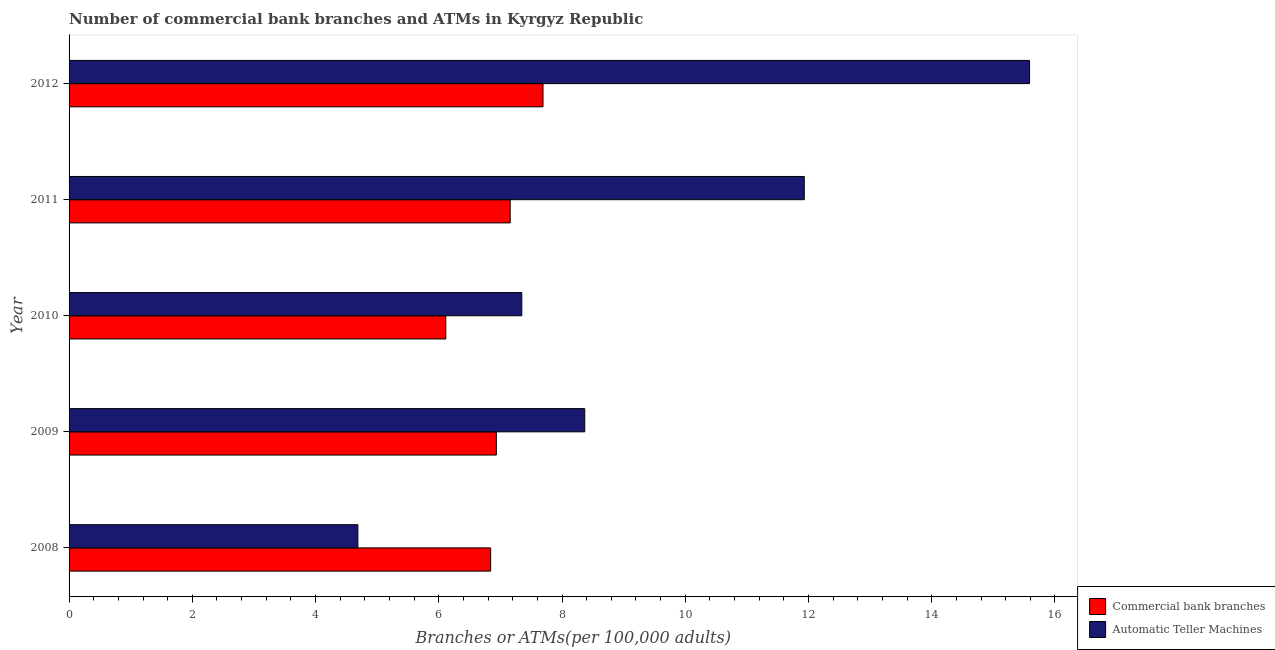How many different coloured bars are there?
Ensure brevity in your answer.  2. How many groups of bars are there?
Your answer should be compact. 5. Are the number of bars on each tick of the Y-axis equal?
Make the answer very short. Yes. How many bars are there on the 2nd tick from the top?
Keep it short and to the point. 2. What is the label of the 1st group of bars from the top?
Offer a terse response. 2012. What is the number of commercal bank branches in 2008?
Provide a succinct answer. 6.84. Across all years, what is the maximum number of atms?
Offer a very short reply. 15.59. Across all years, what is the minimum number of commercal bank branches?
Make the answer very short. 6.11. What is the total number of commercal bank branches in the graph?
Your answer should be very brief. 34.74. What is the difference between the number of commercal bank branches in 2009 and that in 2010?
Your response must be concise. 0.82. What is the difference between the number of commercal bank branches in 2009 and the number of atms in 2012?
Offer a terse response. -8.65. What is the average number of commercal bank branches per year?
Give a very brief answer. 6.95. In the year 2012, what is the difference between the number of atms and number of commercal bank branches?
Offer a very short reply. 7.9. What is the ratio of the number of atms in 2009 to that in 2012?
Your answer should be compact. 0.54. Is the number of commercal bank branches in 2010 less than that in 2012?
Provide a short and direct response. Yes. Is the difference between the number of atms in 2011 and 2012 greater than the difference between the number of commercal bank branches in 2011 and 2012?
Keep it short and to the point. No. What is the difference between the highest and the second highest number of atms?
Your response must be concise. 3.66. What does the 2nd bar from the top in 2011 represents?
Your answer should be very brief. Commercial bank branches. What does the 1st bar from the bottom in 2012 represents?
Your answer should be very brief. Commercial bank branches. Are all the bars in the graph horizontal?
Provide a succinct answer. Yes. How many years are there in the graph?
Make the answer very short. 5. Does the graph contain grids?
Keep it short and to the point. No. Where does the legend appear in the graph?
Provide a succinct answer. Bottom right. What is the title of the graph?
Give a very brief answer. Number of commercial bank branches and ATMs in Kyrgyz Republic. Does "Primary completion rate" appear as one of the legend labels in the graph?
Provide a short and direct response. No. What is the label or title of the X-axis?
Keep it short and to the point. Branches or ATMs(per 100,0 adults). What is the label or title of the Y-axis?
Offer a very short reply. Year. What is the Branches or ATMs(per 100,000 adults) of Commercial bank branches in 2008?
Provide a succinct answer. 6.84. What is the Branches or ATMs(per 100,000 adults) of Automatic Teller Machines in 2008?
Ensure brevity in your answer.  4.69. What is the Branches or ATMs(per 100,000 adults) of Commercial bank branches in 2009?
Provide a succinct answer. 6.93. What is the Branches or ATMs(per 100,000 adults) in Automatic Teller Machines in 2009?
Give a very brief answer. 8.37. What is the Branches or ATMs(per 100,000 adults) in Commercial bank branches in 2010?
Your answer should be very brief. 6.11. What is the Branches or ATMs(per 100,000 adults) of Automatic Teller Machines in 2010?
Make the answer very short. 7.35. What is the Branches or ATMs(per 100,000 adults) of Commercial bank branches in 2011?
Ensure brevity in your answer.  7.16. What is the Branches or ATMs(per 100,000 adults) in Automatic Teller Machines in 2011?
Provide a succinct answer. 11.93. What is the Branches or ATMs(per 100,000 adults) of Commercial bank branches in 2012?
Provide a short and direct response. 7.69. What is the Branches or ATMs(per 100,000 adults) in Automatic Teller Machines in 2012?
Provide a short and direct response. 15.59. Across all years, what is the maximum Branches or ATMs(per 100,000 adults) of Commercial bank branches?
Your answer should be compact. 7.69. Across all years, what is the maximum Branches or ATMs(per 100,000 adults) in Automatic Teller Machines?
Ensure brevity in your answer.  15.59. Across all years, what is the minimum Branches or ATMs(per 100,000 adults) in Commercial bank branches?
Ensure brevity in your answer.  6.11. Across all years, what is the minimum Branches or ATMs(per 100,000 adults) of Automatic Teller Machines?
Ensure brevity in your answer.  4.69. What is the total Branches or ATMs(per 100,000 adults) of Commercial bank branches in the graph?
Make the answer very short. 34.74. What is the total Branches or ATMs(per 100,000 adults) of Automatic Teller Machines in the graph?
Keep it short and to the point. 47.92. What is the difference between the Branches or ATMs(per 100,000 adults) of Commercial bank branches in 2008 and that in 2009?
Give a very brief answer. -0.09. What is the difference between the Branches or ATMs(per 100,000 adults) in Automatic Teller Machines in 2008 and that in 2009?
Provide a succinct answer. -3.68. What is the difference between the Branches or ATMs(per 100,000 adults) in Commercial bank branches in 2008 and that in 2010?
Offer a terse response. 0.73. What is the difference between the Branches or ATMs(per 100,000 adults) in Automatic Teller Machines in 2008 and that in 2010?
Give a very brief answer. -2.66. What is the difference between the Branches or ATMs(per 100,000 adults) in Commercial bank branches in 2008 and that in 2011?
Offer a very short reply. -0.32. What is the difference between the Branches or ATMs(per 100,000 adults) of Automatic Teller Machines in 2008 and that in 2011?
Offer a terse response. -7.24. What is the difference between the Branches or ATMs(per 100,000 adults) of Commercial bank branches in 2008 and that in 2012?
Offer a terse response. -0.85. What is the difference between the Branches or ATMs(per 100,000 adults) of Automatic Teller Machines in 2008 and that in 2012?
Your answer should be very brief. -10.9. What is the difference between the Branches or ATMs(per 100,000 adults) in Commercial bank branches in 2009 and that in 2010?
Provide a succinct answer. 0.82. What is the difference between the Branches or ATMs(per 100,000 adults) of Automatic Teller Machines in 2009 and that in 2010?
Provide a short and direct response. 1.02. What is the difference between the Branches or ATMs(per 100,000 adults) of Commercial bank branches in 2009 and that in 2011?
Make the answer very short. -0.22. What is the difference between the Branches or ATMs(per 100,000 adults) of Automatic Teller Machines in 2009 and that in 2011?
Offer a very short reply. -3.56. What is the difference between the Branches or ATMs(per 100,000 adults) of Commercial bank branches in 2009 and that in 2012?
Your answer should be compact. -0.76. What is the difference between the Branches or ATMs(per 100,000 adults) of Automatic Teller Machines in 2009 and that in 2012?
Make the answer very short. -7.22. What is the difference between the Branches or ATMs(per 100,000 adults) of Commercial bank branches in 2010 and that in 2011?
Your response must be concise. -1.05. What is the difference between the Branches or ATMs(per 100,000 adults) in Automatic Teller Machines in 2010 and that in 2011?
Offer a terse response. -4.58. What is the difference between the Branches or ATMs(per 100,000 adults) in Commercial bank branches in 2010 and that in 2012?
Ensure brevity in your answer.  -1.58. What is the difference between the Branches or ATMs(per 100,000 adults) of Automatic Teller Machines in 2010 and that in 2012?
Provide a short and direct response. -8.24. What is the difference between the Branches or ATMs(per 100,000 adults) in Commercial bank branches in 2011 and that in 2012?
Your answer should be compact. -0.53. What is the difference between the Branches or ATMs(per 100,000 adults) of Automatic Teller Machines in 2011 and that in 2012?
Offer a terse response. -3.66. What is the difference between the Branches or ATMs(per 100,000 adults) of Commercial bank branches in 2008 and the Branches or ATMs(per 100,000 adults) of Automatic Teller Machines in 2009?
Your answer should be compact. -1.53. What is the difference between the Branches or ATMs(per 100,000 adults) of Commercial bank branches in 2008 and the Branches or ATMs(per 100,000 adults) of Automatic Teller Machines in 2010?
Keep it short and to the point. -0.51. What is the difference between the Branches or ATMs(per 100,000 adults) of Commercial bank branches in 2008 and the Branches or ATMs(per 100,000 adults) of Automatic Teller Machines in 2011?
Provide a succinct answer. -5.09. What is the difference between the Branches or ATMs(per 100,000 adults) in Commercial bank branches in 2008 and the Branches or ATMs(per 100,000 adults) in Automatic Teller Machines in 2012?
Ensure brevity in your answer.  -8.75. What is the difference between the Branches or ATMs(per 100,000 adults) in Commercial bank branches in 2009 and the Branches or ATMs(per 100,000 adults) in Automatic Teller Machines in 2010?
Make the answer very short. -0.41. What is the difference between the Branches or ATMs(per 100,000 adults) in Commercial bank branches in 2009 and the Branches or ATMs(per 100,000 adults) in Automatic Teller Machines in 2011?
Keep it short and to the point. -5. What is the difference between the Branches or ATMs(per 100,000 adults) of Commercial bank branches in 2009 and the Branches or ATMs(per 100,000 adults) of Automatic Teller Machines in 2012?
Provide a short and direct response. -8.65. What is the difference between the Branches or ATMs(per 100,000 adults) of Commercial bank branches in 2010 and the Branches or ATMs(per 100,000 adults) of Automatic Teller Machines in 2011?
Ensure brevity in your answer.  -5.82. What is the difference between the Branches or ATMs(per 100,000 adults) in Commercial bank branches in 2010 and the Branches or ATMs(per 100,000 adults) in Automatic Teller Machines in 2012?
Your answer should be very brief. -9.47. What is the difference between the Branches or ATMs(per 100,000 adults) of Commercial bank branches in 2011 and the Branches or ATMs(per 100,000 adults) of Automatic Teller Machines in 2012?
Offer a terse response. -8.43. What is the average Branches or ATMs(per 100,000 adults) of Commercial bank branches per year?
Ensure brevity in your answer.  6.95. What is the average Branches or ATMs(per 100,000 adults) of Automatic Teller Machines per year?
Offer a very short reply. 9.58. In the year 2008, what is the difference between the Branches or ATMs(per 100,000 adults) of Commercial bank branches and Branches or ATMs(per 100,000 adults) of Automatic Teller Machines?
Offer a very short reply. 2.15. In the year 2009, what is the difference between the Branches or ATMs(per 100,000 adults) in Commercial bank branches and Branches or ATMs(per 100,000 adults) in Automatic Teller Machines?
Provide a succinct answer. -1.43. In the year 2010, what is the difference between the Branches or ATMs(per 100,000 adults) in Commercial bank branches and Branches or ATMs(per 100,000 adults) in Automatic Teller Machines?
Provide a succinct answer. -1.23. In the year 2011, what is the difference between the Branches or ATMs(per 100,000 adults) in Commercial bank branches and Branches or ATMs(per 100,000 adults) in Automatic Teller Machines?
Make the answer very short. -4.77. In the year 2012, what is the difference between the Branches or ATMs(per 100,000 adults) of Commercial bank branches and Branches or ATMs(per 100,000 adults) of Automatic Teller Machines?
Your response must be concise. -7.9. What is the ratio of the Branches or ATMs(per 100,000 adults) in Commercial bank branches in 2008 to that in 2009?
Your response must be concise. 0.99. What is the ratio of the Branches or ATMs(per 100,000 adults) of Automatic Teller Machines in 2008 to that in 2009?
Offer a terse response. 0.56. What is the ratio of the Branches or ATMs(per 100,000 adults) of Commercial bank branches in 2008 to that in 2010?
Make the answer very short. 1.12. What is the ratio of the Branches or ATMs(per 100,000 adults) of Automatic Teller Machines in 2008 to that in 2010?
Your response must be concise. 0.64. What is the ratio of the Branches or ATMs(per 100,000 adults) of Commercial bank branches in 2008 to that in 2011?
Keep it short and to the point. 0.96. What is the ratio of the Branches or ATMs(per 100,000 adults) in Automatic Teller Machines in 2008 to that in 2011?
Keep it short and to the point. 0.39. What is the ratio of the Branches or ATMs(per 100,000 adults) in Commercial bank branches in 2008 to that in 2012?
Provide a short and direct response. 0.89. What is the ratio of the Branches or ATMs(per 100,000 adults) in Automatic Teller Machines in 2008 to that in 2012?
Your answer should be compact. 0.3. What is the ratio of the Branches or ATMs(per 100,000 adults) of Commercial bank branches in 2009 to that in 2010?
Provide a short and direct response. 1.13. What is the ratio of the Branches or ATMs(per 100,000 adults) in Automatic Teller Machines in 2009 to that in 2010?
Your response must be concise. 1.14. What is the ratio of the Branches or ATMs(per 100,000 adults) in Commercial bank branches in 2009 to that in 2011?
Provide a succinct answer. 0.97. What is the ratio of the Branches or ATMs(per 100,000 adults) of Automatic Teller Machines in 2009 to that in 2011?
Keep it short and to the point. 0.7. What is the ratio of the Branches or ATMs(per 100,000 adults) of Commercial bank branches in 2009 to that in 2012?
Offer a terse response. 0.9. What is the ratio of the Branches or ATMs(per 100,000 adults) of Automatic Teller Machines in 2009 to that in 2012?
Provide a short and direct response. 0.54. What is the ratio of the Branches or ATMs(per 100,000 adults) in Commercial bank branches in 2010 to that in 2011?
Make the answer very short. 0.85. What is the ratio of the Branches or ATMs(per 100,000 adults) of Automatic Teller Machines in 2010 to that in 2011?
Ensure brevity in your answer.  0.62. What is the ratio of the Branches or ATMs(per 100,000 adults) of Commercial bank branches in 2010 to that in 2012?
Offer a terse response. 0.79. What is the ratio of the Branches or ATMs(per 100,000 adults) of Automatic Teller Machines in 2010 to that in 2012?
Keep it short and to the point. 0.47. What is the ratio of the Branches or ATMs(per 100,000 adults) of Commercial bank branches in 2011 to that in 2012?
Provide a short and direct response. 0.93. What is the ratio of the Branches or ATMs(per 100,000 adults) in Automatic Teller Machines in 2011 to that in 2012?
Provide a succinct answer. 0.77. What is the difference between the highest and the second highest Branches or ATMs(per 100,000 adults) of Commercial bank branches?
Provide a short and direct response. 0.53. What is the difference between the highest and the second highest Branches or ATMs(per 100,000 adults) of Automatic Teller Machines?
Make the answer very short. 3.66. What is the difference between the highest and the lowest Branches or ATMs(per 100,000 adults) of Commercial bank branches?
Your response must be concise. 1.58. What is the difference between the highest and the lowest Branches or ATMs(per 100,000 adults) of Automatic Teller Machines?
Your answer should be compact. 10.9. 